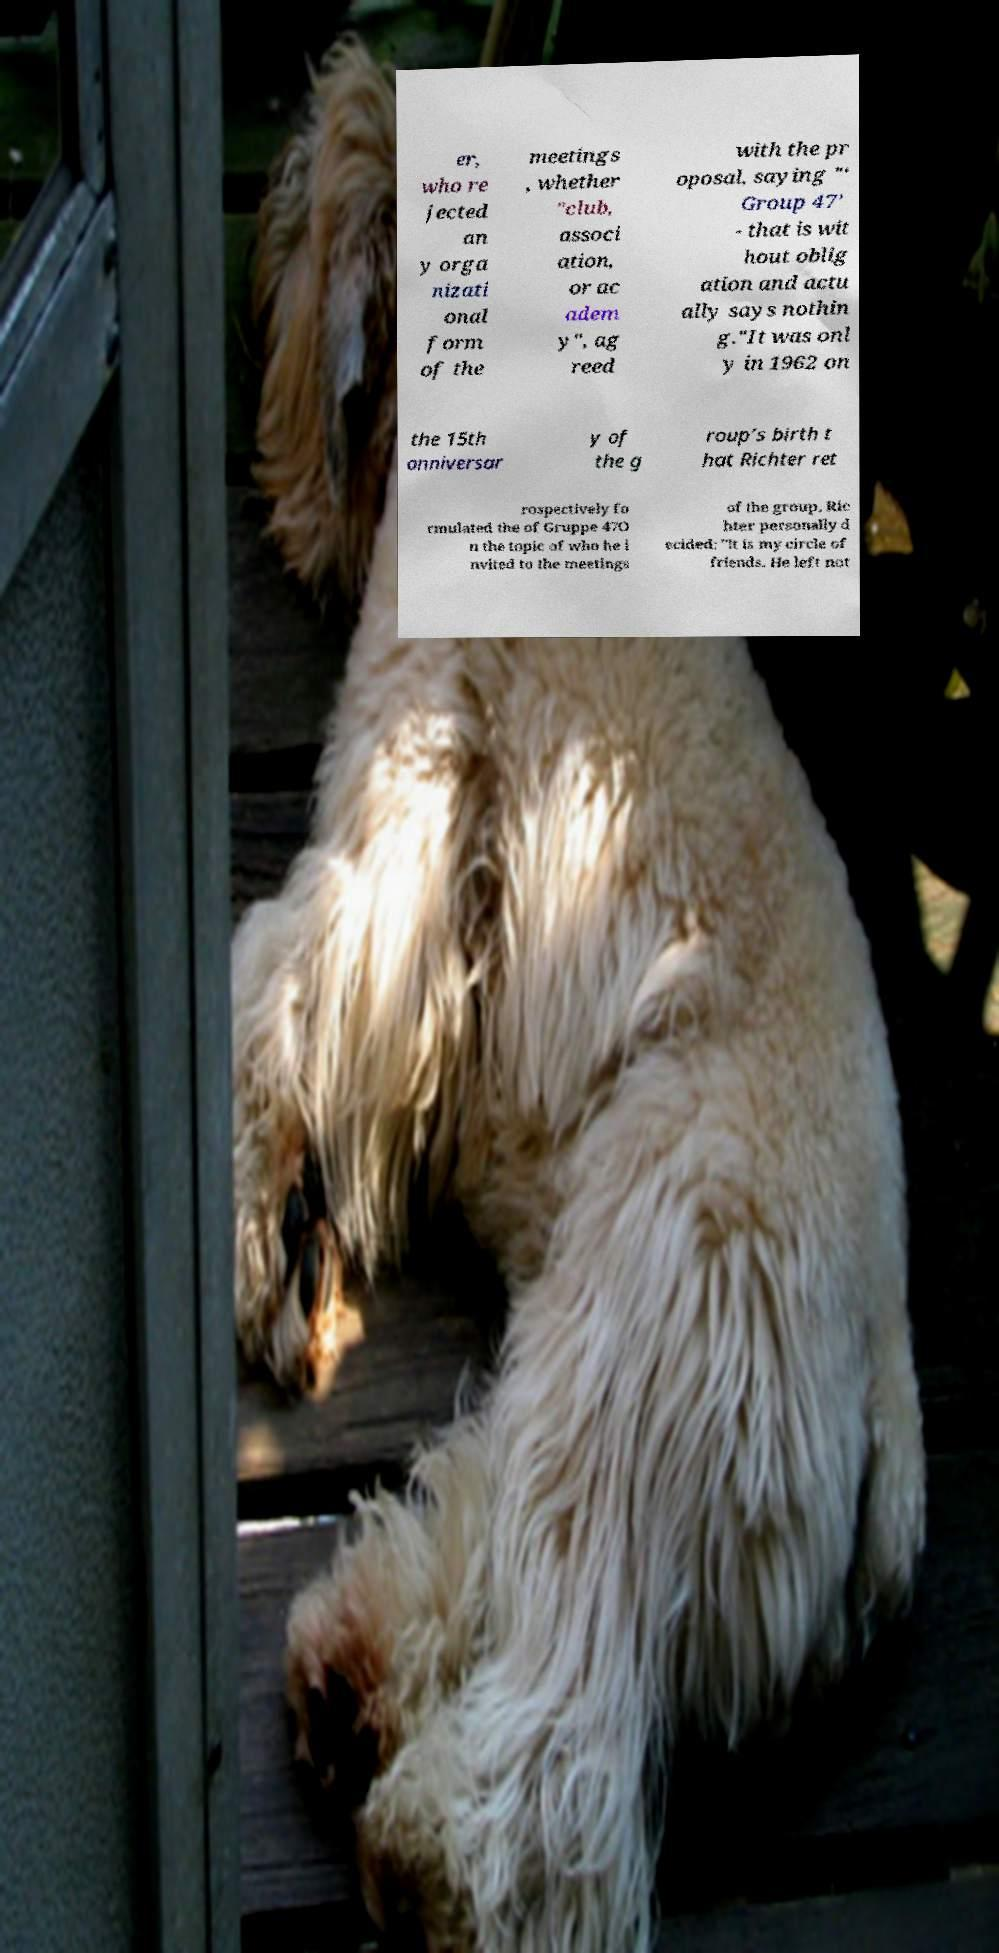Can you accurately transcribe the text from the provided image for me? er, who re jected an y orga nizati onal form of the meetings , whether "club, associ ation, or ac adem y", ag reed with the pr oposal, saying "‘ Group 47’ - that is wit hout oblig ation and actu ally says nothin g."It was onl y in 1962 on the 15th anniversar y of the g roup’s birth t hat Richter ret rospectively fo rmulated the of Gruppe 47O n the topic of who he i nvited to the meetings of the group, Ric hter personally d ecided: "It is my circle of friends. He left not 